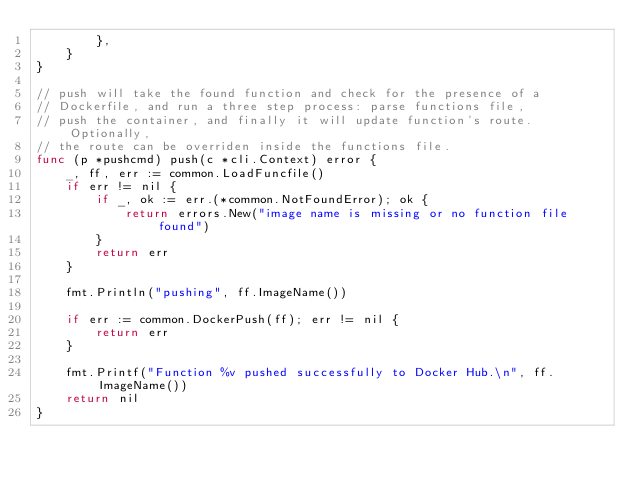Convert code to text. <code><loc_0><loc_0><loc_500><loc_500><_Go_>		},
	}
}

// push will take the found function and check for the presence of a
// Dockerfile, and run a three step process: parse functions file,
// push the container, and finally it will update function's route. Optionally,
// the route can be overriden inside the functions file.
func (p *pushcmd) push(c *cli.Context) error {
	_, ff, err := common.LoadFuncfile()
	if err != nil {
		if _, ok := err.(*common.NotFoundError); ok {
			return errors.New("image name is missing or no function file found")
		}
		return err
	}

	fmt.Println("pushing", ff.ImageName())

	if err := common.DockerPush(ff); err != nil {
		return err
	}

	fmt.Printf("Function %v pushed successfully to Docker Hub.\n", ff.ImageName())
	return nil
}
</code> 